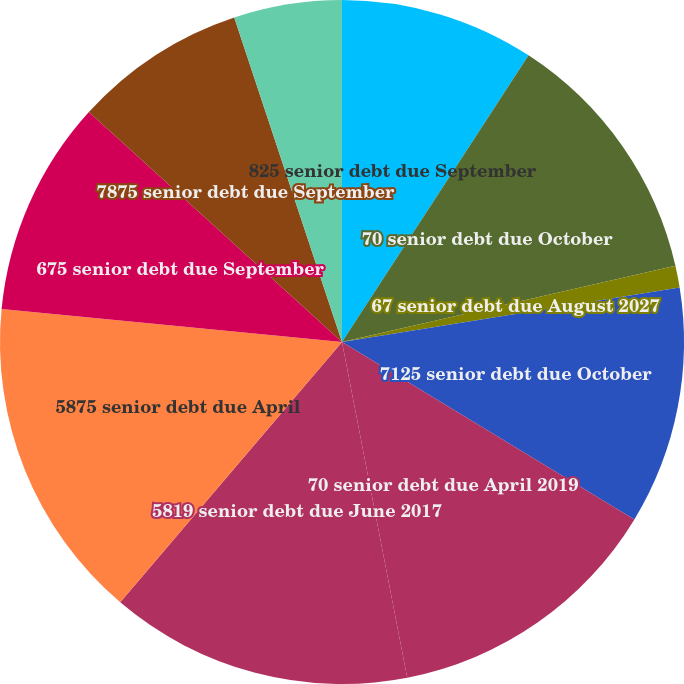<chart> <loc_0><loc_0><loc_500><loc_500><pie_chart><fcel>825 senior debt due September<fcel>70 senior debt due October<fcel>67 senior debt due August 2027<fcel>7125 senior debt due October<fcel>70 senior debt due April 2019<fcel>5819 senior debt due June 2017<fcel>5875 senior debt due April<fcel>675 senior debt due September<fcel>7875 senior debt due September<fcel>250 to 959 lease financing<nl><fcel>9.18%<fcel>12.24%<fcel>1.03%<fcel>11.22%<fcel>13.26%<fcel>14.28%<fcel>15.3%<fcel>10.2%<fcel>8.16%<fcel>5.1%<nl></chart> 